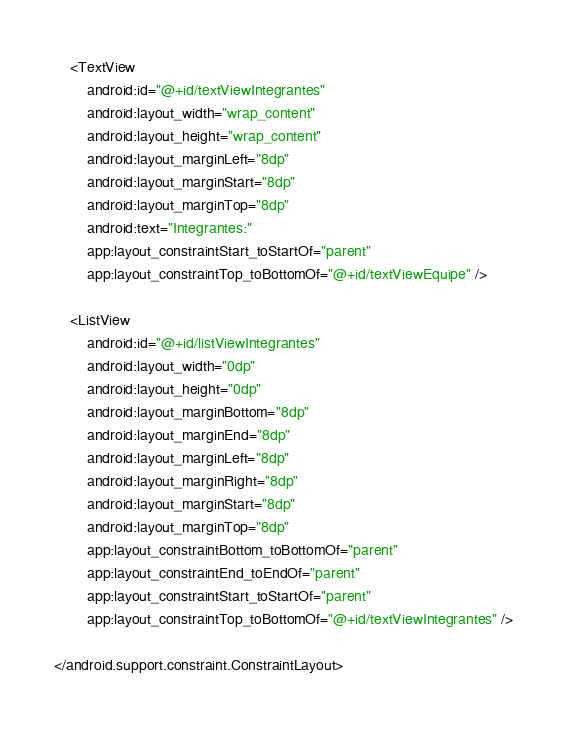<code> <loc_0><loc_0><loc_500><loc_500><_XML_>
    <TextView
        android:id="@+id/textViewIntegrantes"
        android:layout_width="wrap_content"
        android:layout_height="wrap_content"
        android:layout_marginLeft="8dp"
        android:layout_marginStart="8dp"
        android:layout_marginTop="8dp"
        android:text="Integrantes:"
        app:layout_constraintStart_toStartOf="parent"
        app:layout_constraintTop_toBottomOf="@+id/textViewEquipe" />

    <ListView
        android:id="@+id/listViewIntegrantes"
        android:layout_width="0dp"
        android:layout_height="0dp"
        android:layout_marginBottom="8dp"
        android:layout_marginEnd="8dp"
        android:layout_marginLeft="8dp"
        android:layout_marginRight="8dp"
        android:layout_marginStart="8dp"
        android:layout_marginTop="8dp"
        app:layout_constraintBottom_toBottomOf="parent"
        app:layout_constraintEnd_toEndOf="parent"
        app:layout_constraintStart_toStartOf="parent"
        app:layout_constraintTop_toBottomOf="@+id/textViewIntegrantes" />

</android.support.constraint.ConstraintLayout></code> 